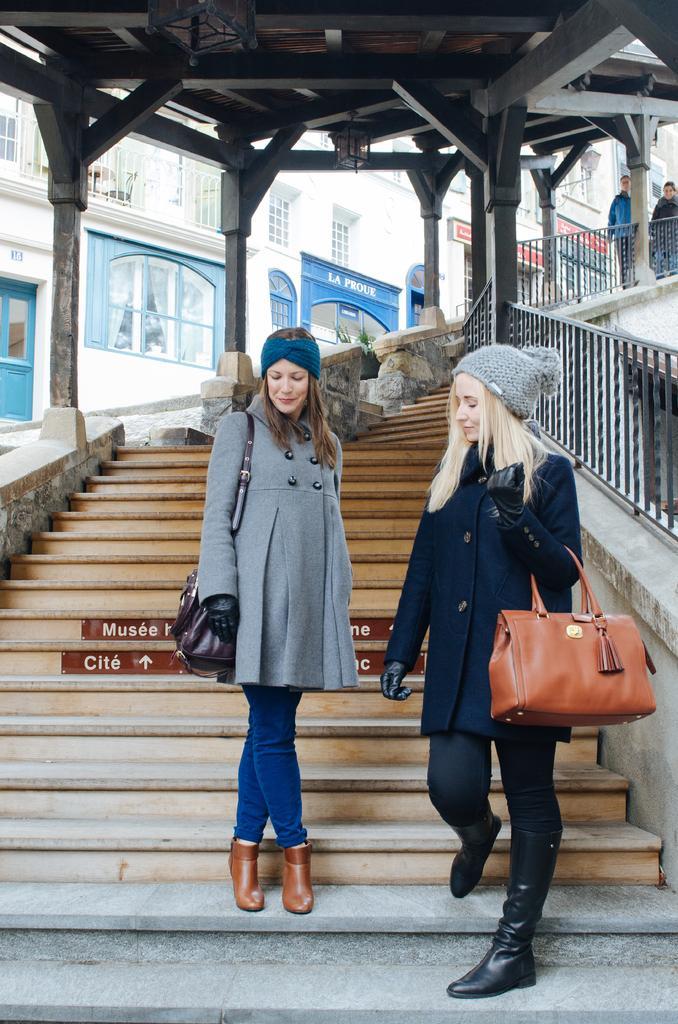Could you give a brief overview of what you see in this image? In the image we can see there are women who are standing on stairs and the woman is holding bag in her hand and they are wearing caps. 